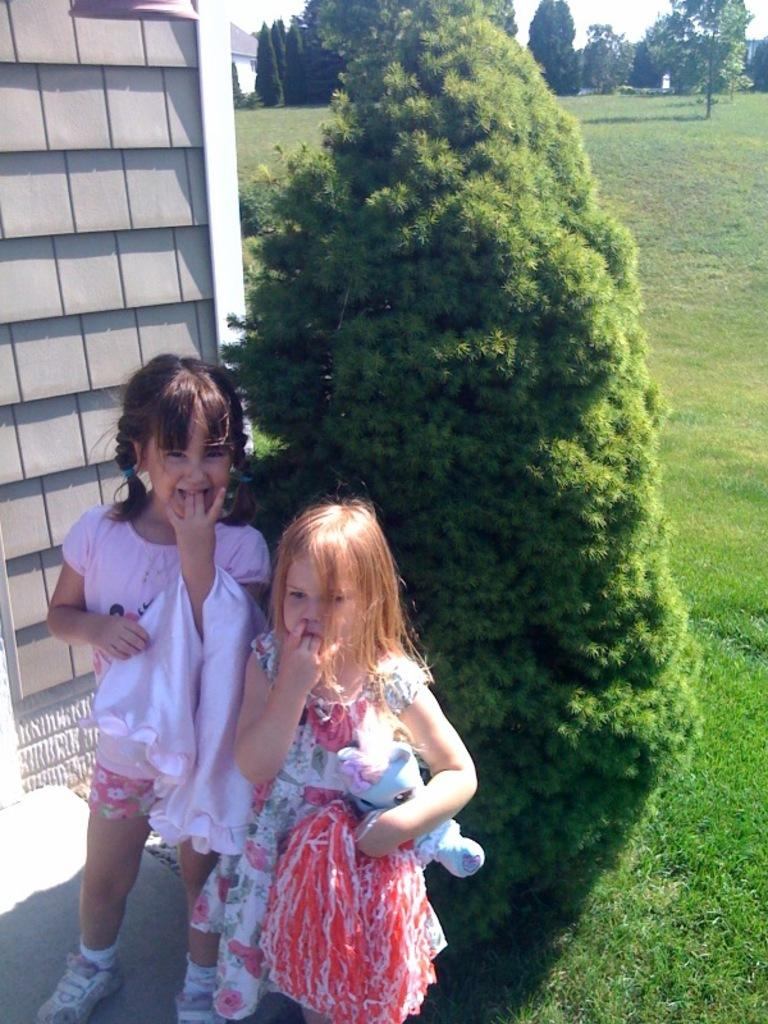How many kids are present in the image? There are two kids in the image. What are the kids holding in their hands? One kid is holding a doll, and the other kid is holding a cloth. What can be seen in the background of the image? There is a building, trees, and grass in the background of the image. What type of finger can be seen holding the doll in the image? There is no finger holding the doll in the image; it is the kid's hand that is holding the doll. Where is the store located in the image? There is no store present in the image. 